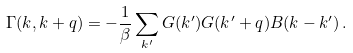Convert formula to latex. <formula><loc_0><loc_0><loc_500><loc_500>\Gamma ( k , k + q ) = - \frac { 1 } { \beta } \sum _ { k ^ { \prime } } G ( k ^ { \prime } ) G ( k ^ { \prime } + q ) B ( k - k ^ { \prime } ) \, .</formula> 